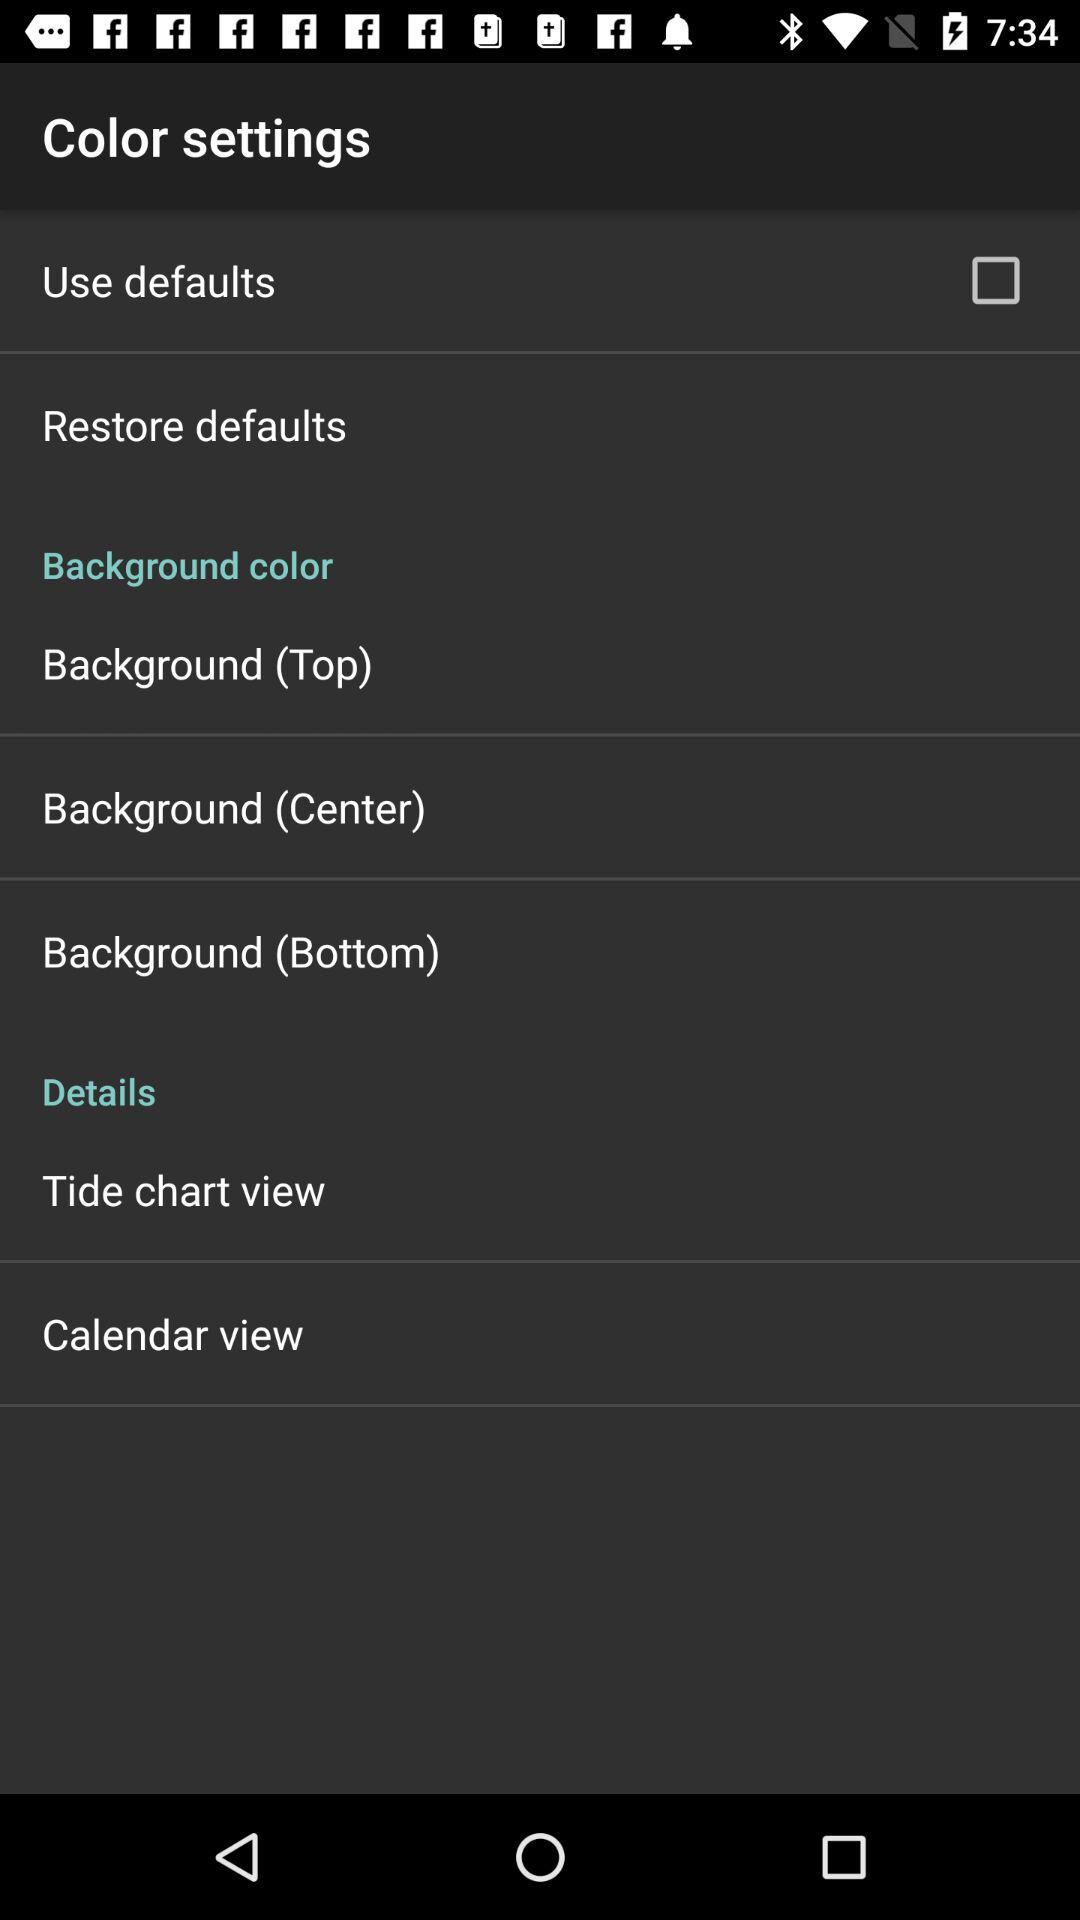How many background color options are there?
Answer the question using a single word or phrase. 3 